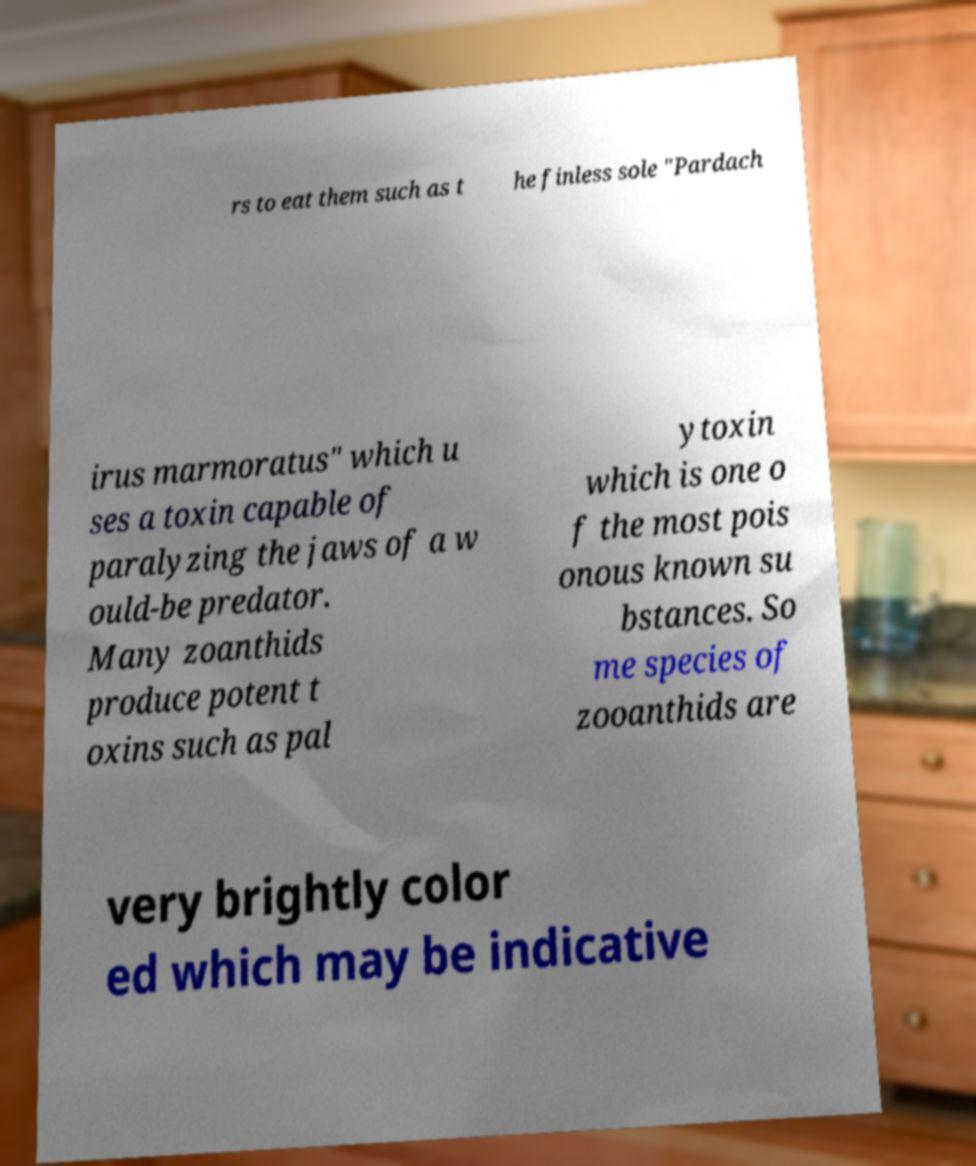Could you assist in decoding the text presented in this image and type it out clearly? rs to eat them such as t he finless sole "Pardach irus marmoratus" which u ses a toxin capable of paralyzing the jaws of a w ould-be predator. Many zoanthids produce potent t oxins such as pal ytoxin which is one o f the most pois onous known su bstances. So me species of zooanthids are very brightly color ed which may be indicative 